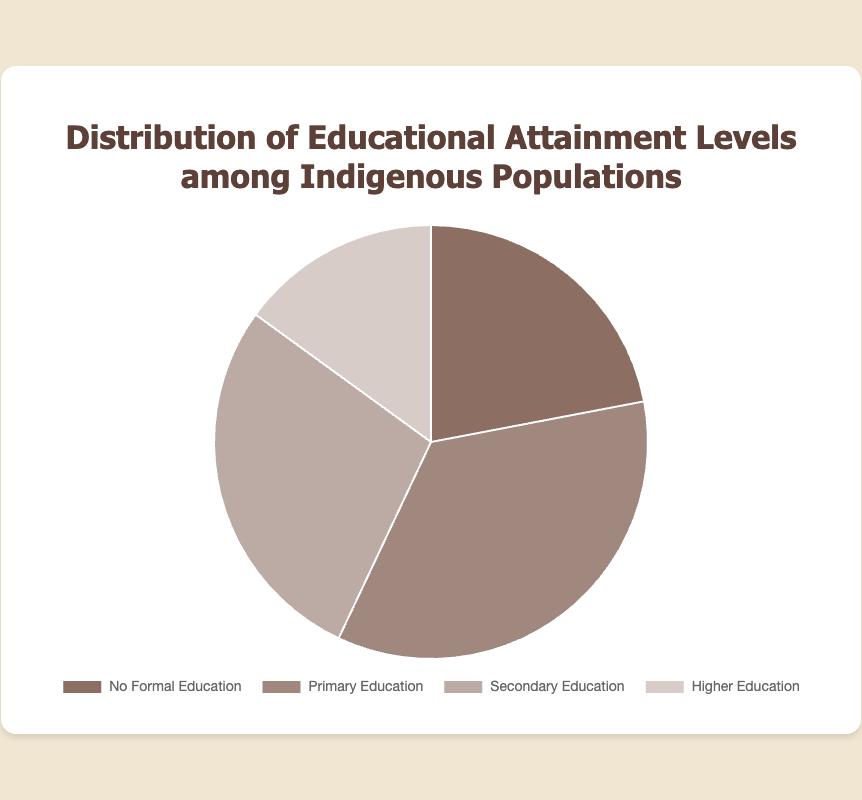What percentage of the population has at least a secondary education? To determine this, sum the percentages of the "Secondary Education" and "Higher Education" categories: 28% + 15% = 43%.
Answer: 43% Which educational category has the highest percentage of the population? Comparing the percentages of all categories, "Primary Education" has the highest percentage at 35%.
Answer: Primary Education What is the difference in population percentages between those with no formal education and those with higher education? Subtract the percentage of "Higher Education" from "No Formal Education": 22% - 15% = 7%.
Answer: 7% What is the combined percentage of the population that has either no formal education or only primary education? Sum the percentages of "No Formal Education" and "Primary Education": 22% + 35% = 57%.
Answer: 57% Which category has a larger population percentage: those with primary education or those with secondary education? Compare the percentages: "Primary Education" at 35% versus "Secondary Education" at 28%. Primary education has a larger population percentage.
Answer: Primary Education What is the average percentage of the population across all educational categories? Add all category percentages and divide by the number of categories: (22% + 35% + 28% + 15%) / 4 = 25%.
Answer: 25% What is the visual color representing the category with the smallest population percentage in the chart? The chart shows "Higher Education" with the smallest percentage (15%), and the color representing it is a lighter shade (d7ccc8).
Answer: Light brown Which two educational categories together constitute just over half of the population? "Primary Education" (35%) and "Secondary Education" (28%) together form 63%, which is just over half the population.
Answer: Primary Education and Secondary Education 